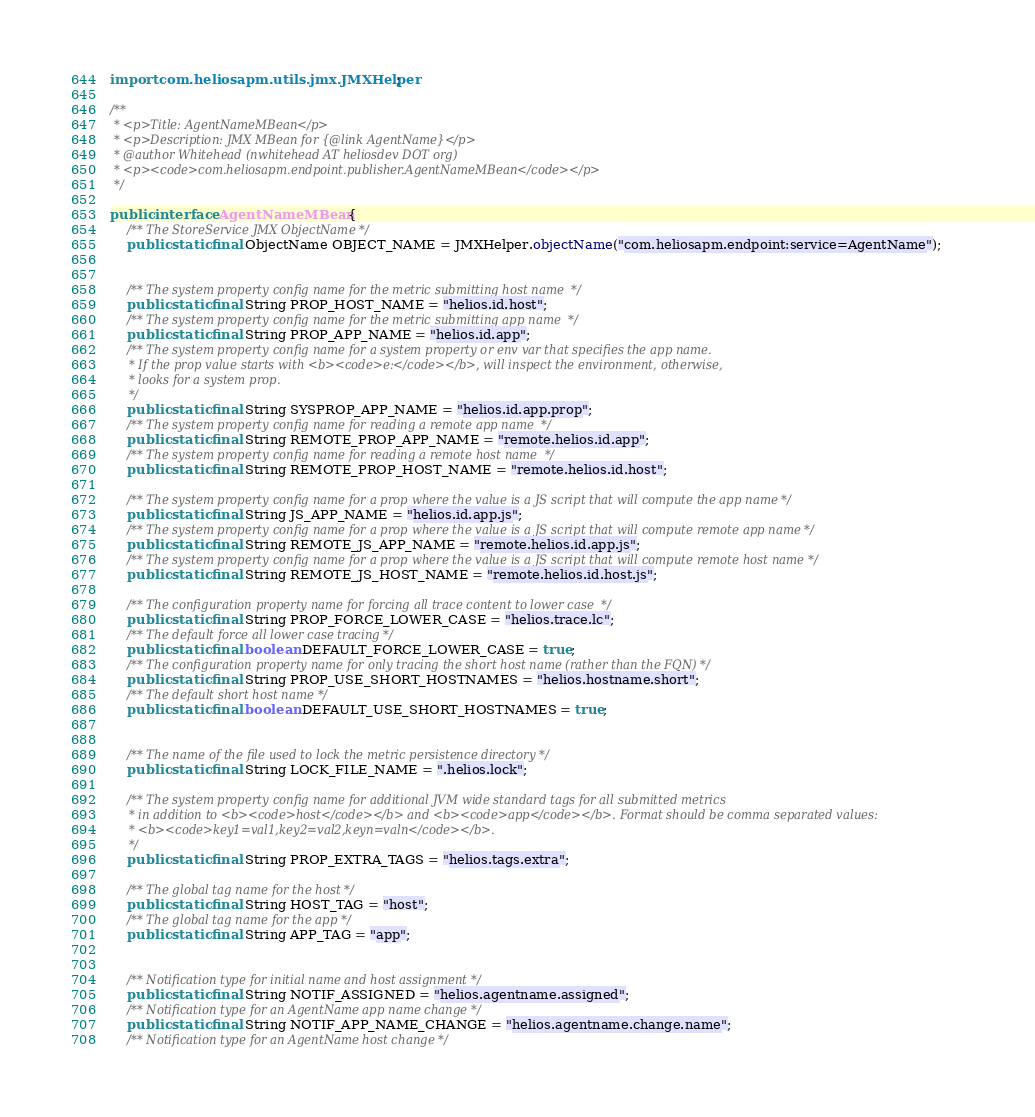Convert code to text. <code><loc_0><loc_0><loc_500><loc_500><_Java_>
import com.heliosapm.utils.jmx.JMXHelper;

/**
 * <p>Title: AgentNameMBean</p>
 * <p>Description: JMX MBean for {@link AgentName}</p> 
 * @author Whitehead (nwhitehead AT heliosdev DOT org)
 * <p><code>com.heliosapm.endpoint.publisher.AgentNameMBean</code></p>
 */

public interface AgentNameMBean {
	/** The StoreService JMX ObjectName */
	public static final ObjectName OBJECT_NAME = JMXHelper.objectName("com.heliosapm.endpoint:service=AgentName");
	
	
	/** The system property config name for the metric submitting host name  */
	public static final String PROP_HOST_NAME = "helios.id.host";
	/** The system property config name for the metric submitting app name  */
	public static final String PROP_APP_NAME = "helios.id.app";
	/** The system property config name for a system property or env var that specifies the app name.
	 * If the prop value starts with <b><code>e:</code></b>, will inspect the environment, otherwise,
	 * looks for a system prop. 
	 */ 
	public static final String SYSPROP_APP_NAME = "helios.id.app.prop";
	/** The system property config name for reading a remote app name  */
	public static final String REMOTE_PROP_APP_NAME = "remote.helios.id.app";
	/** The system property config name for reading a remote host name  */
	public static final String REMOTE_PROP_HOST_NAME = "remote.helios.id.host";
	
	/** The system property config name for a prop where the value is a JS script that will compute the app name */ 
	public static final String JS_APP_NAME = "helios.id.app.js";
	/** The system property config name for a prop where the value is a JS script that will compute remote app name */ 
	public static final String REMOTE_JS_APP_NAME = "remote.helios.id.app.js";
	/** The system property config name for a prop where the value is a JS script that will compute remote host name */ 
	public static final String REMOTE_JS_HOST_NAME = "remote.helios.id.host.js";
	
	/** The configuration property name for forcing all trace content to lower case  */
	public static final String PROP_FORCE_LOWER_CASE = "helios.trace.lc";
	/** The default force all lower case tracing */
	public static final boolean DEFAULT_FORCE_LOWER_CASE = true;
	/** The configuration property name for only tracing the short host name (rather than the FQN) */
	public static final String PROP_USE_SHORT_HOSTNAMES = "helios.hostname.short";
	/** The default short host name */
	public static final boolean DEFAULT_USE_SHORT_HOSTNAMES = true;
	
	
	/** The name of the file used to lock the metric persistence directory */
	public static final String LOCK_FILE_NAME = ".helios.lock";
	
	/** The system property config name for additional JVM wide standard tags for all submitted metrics
	 * in addition to <b><code>host</code></b> and <b><code>app</code></b>. Format should be comma separated values:
	 * <b><code>key1=val1,key2=val2,keyn=valn</code></b>. 
	 */
	public static final String PROP_EXTRA_TAGS = "helios.tags.extra";
	
    /** The global tag name for the host */
    public static final String HOST_TAG = "host";
    /** The global tag name for the app */
    public static final String APP_TAG = "app";
	
	
	/** Notification type for initial name and host assignment */
	public static final String NOTIF_ASSIGNED = "helios.agentname.assigned";
	/** Notification type for an AgentName app name change */
	public static final String NOTIF_APP_NAME_CHANGE = "helios.agentname.change.name";
	/** Notification type for an AgentName host change */</code> 